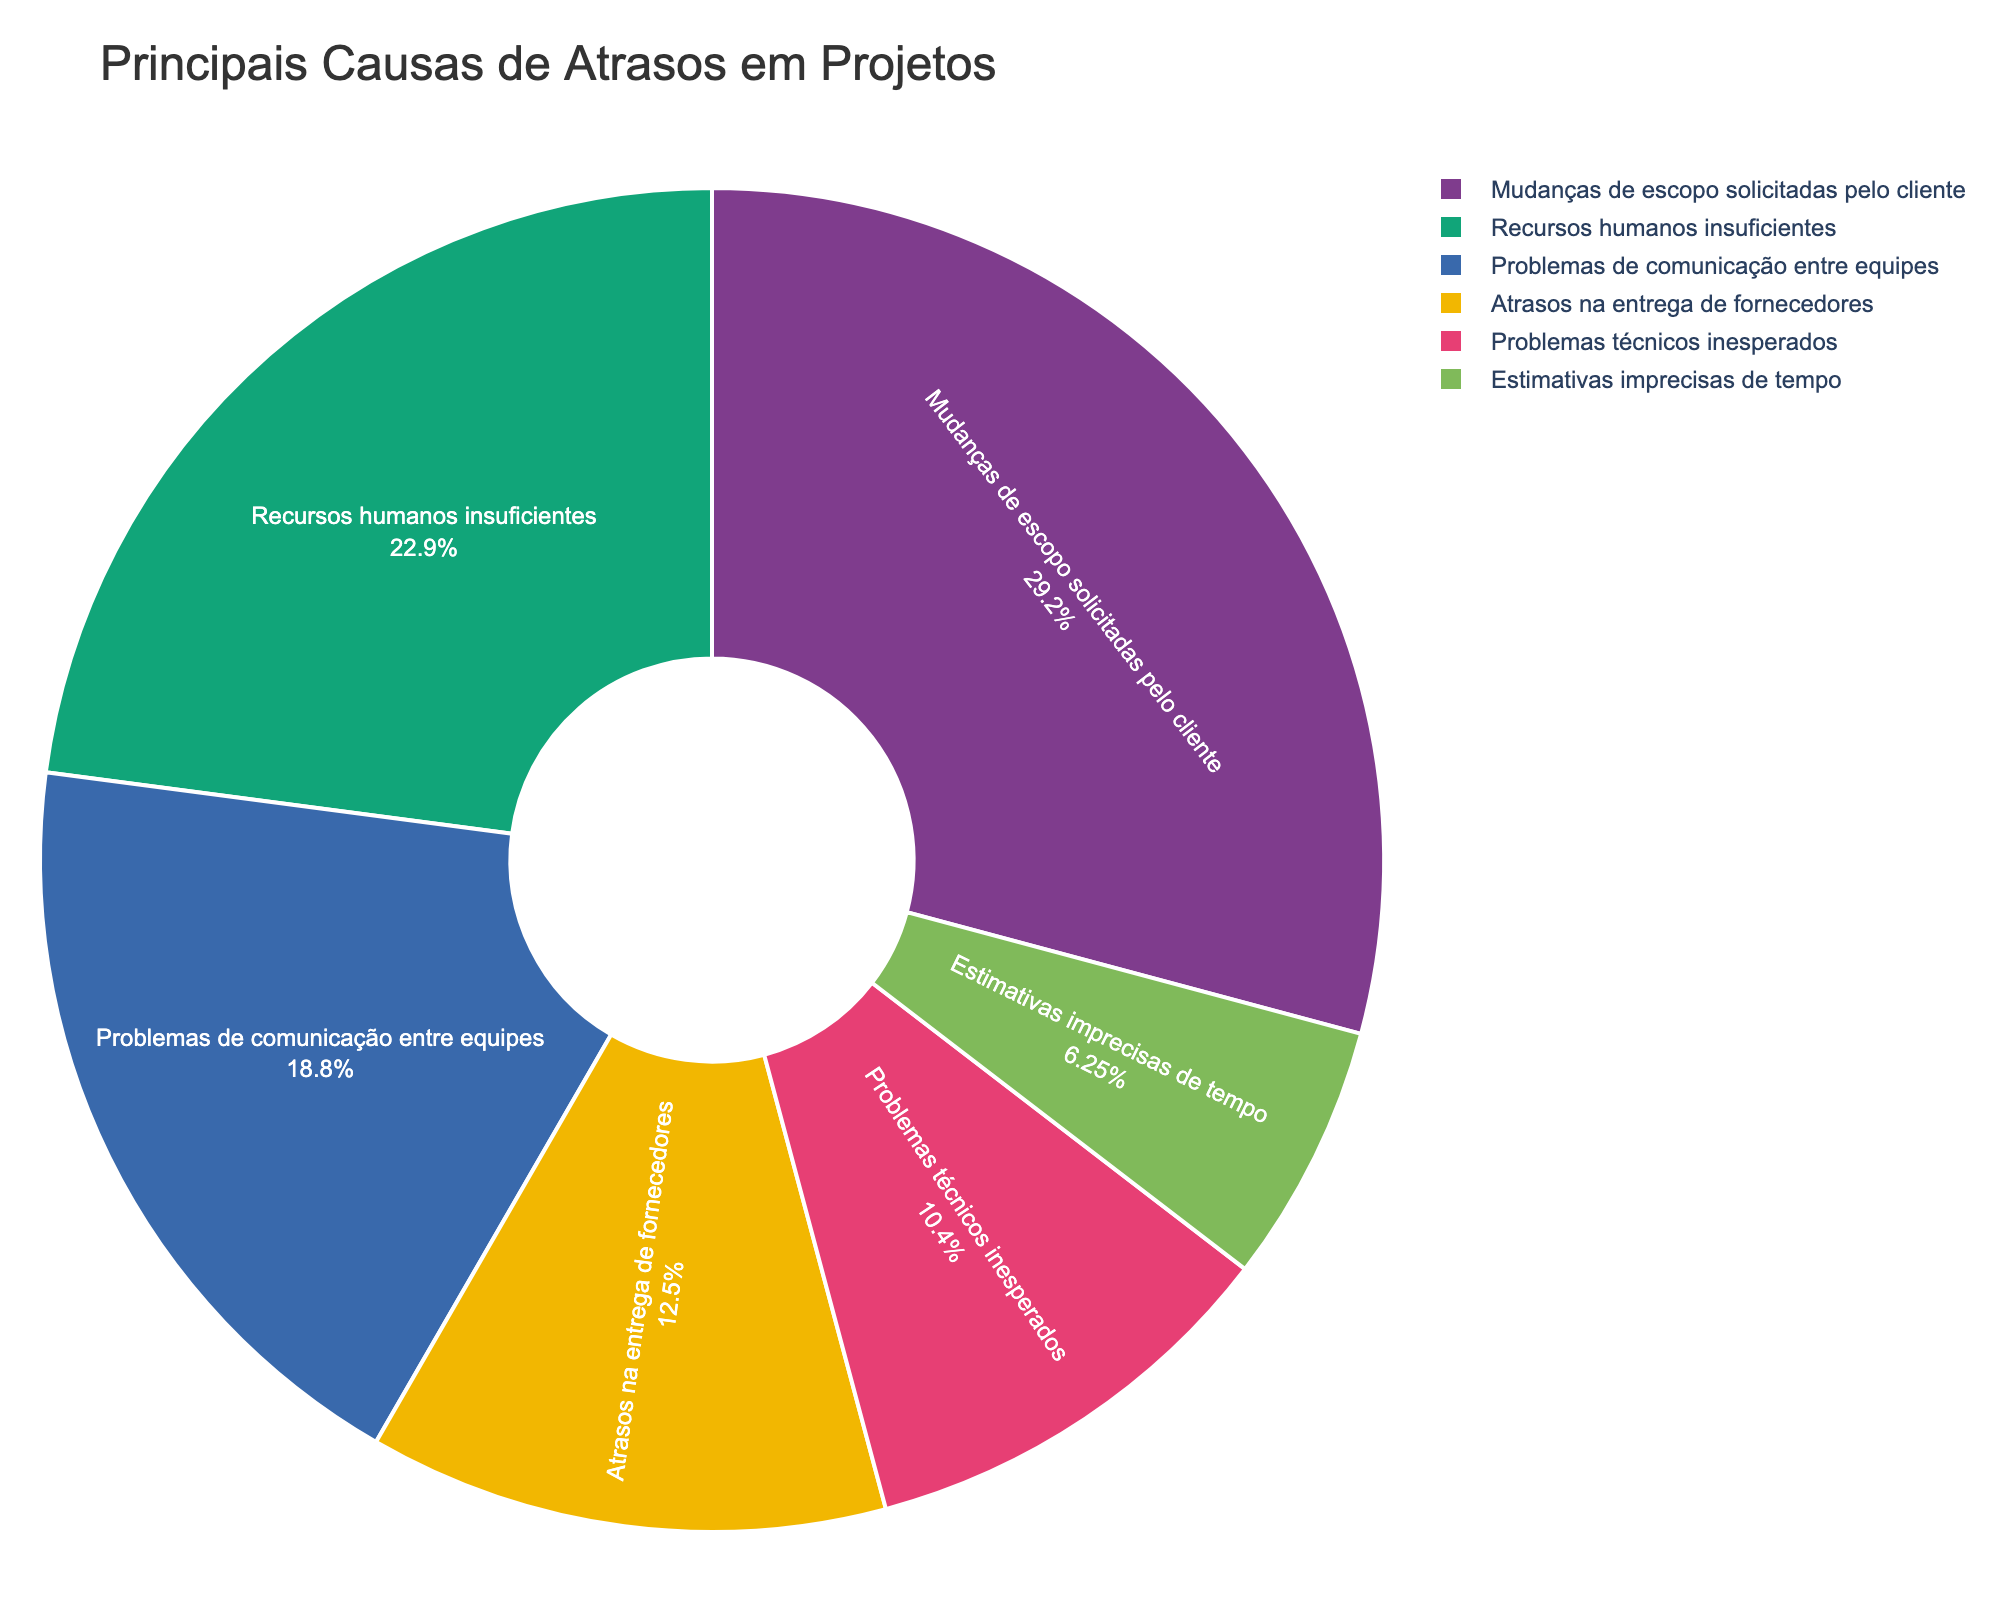Which cause of project delay has the highest percentage? The chart shows that "Mudanças de escopo solicitadas pelo cliente" has the largest segment, indicating it's the leading cause.
Answer: Mudanças de escopo solicitadas pelo cliente What is the combined percentage of delays caused by "recursos humanos insuficientes" and "problemas de comunicação entre equipes"? Sum the percentages of "recursos humanos insuficientes" (22%) and "problemas de comunicação entre equipes" (18%).
Answer: 40% Which factor has the lowest impact on project delays, and what is its percentage? The smallest segment in the pie chart corresponds to "estimativas imprecisas de tempo," indicating it's the least impactful cause of delay.
Answer: Estimativas imprecisas de tempo, 6% How much higher is the percentage of delays caused by "mudanças de escopo solicitadas pelo cliente" compared to "atrasos na entrega de fornecedores"? Subtract the percentage of "atrasos na entrega de fornecedores" (12%) from "mudanças de escopo solicitadas pelo cliente" (28%).
Answer: 16% What percentage of delays are attributed to "problemas técnicos inesperados"? The chart shows that "problemas técnicos inesperados" make up 10% of the delays.
Answer: 10% Is the percentage of delays due to "recursos humanos insuficientes" greater than those due to "problemas de comunicação entre equipes" and by how much? The percentage for "recursos humanos insuficientes" (22%) is higher than "problemas de comunicação entre equipes" (18%). Subtract 18% from 22%.
Answer: 4% What is the total percentage of delays caused by "problemas técnicos inesperados" and "estimativas imprecisas de tempo"? Sum the percentages for "problemas técnicos inesperados" (10%) and "estimativas imprecisas de tempo" (6%).
Answer: 16% Are "atrasos na entrega de fornecedores" responsible for more delays than "problemas técnicos inesperados"? Compare the percentages: "atrasos na entrega de fornecedores" has 12%, which is greater than "problemas técnicos inesperados" at 10%.
Answer: Yes What is the average percentage of the top three causes of project delays? Sum the percentages of the top three causes (28% for "mudanças de escopo solicitadas pelo cliente", 22% for "recursos humanos insuficientes", and 18% for "problemas de comunicação entre equipes") and divide by 3. (28 + 22 + 18) / 3 = 22.67
Answer: 22.67% 